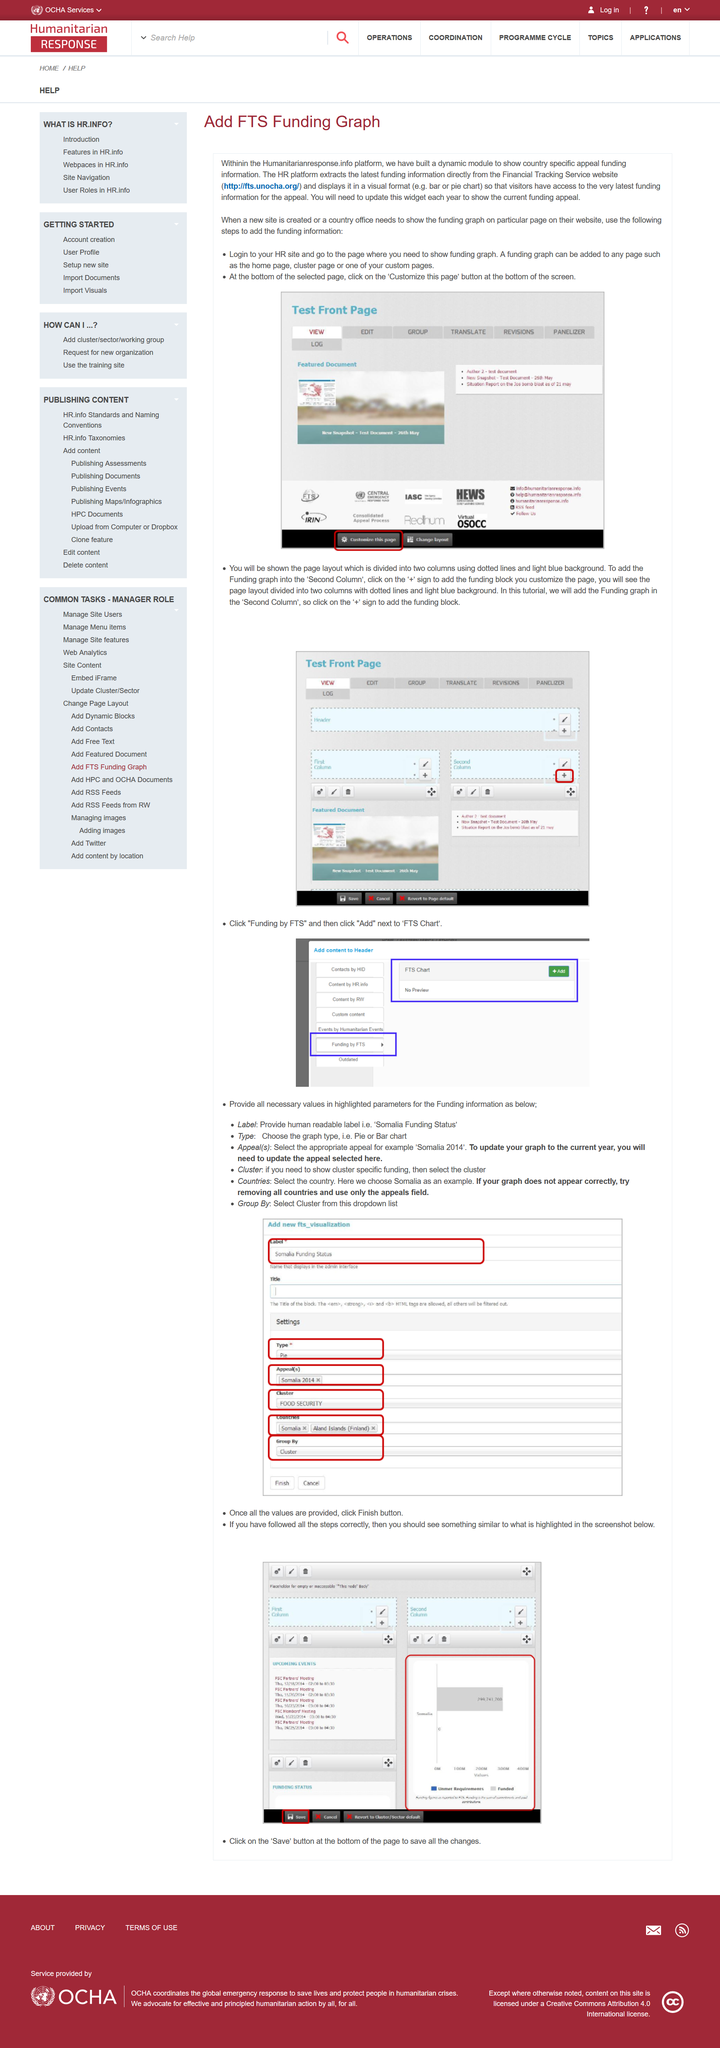Point out several critical features in this image. It is recommended to provide all necessary values in the highlighted parameters. The HR platform obtains information directly from the Financial Tracking Service website. To access the funding graph on the HR website, you must click the 'Customize this page' button located at the bottom of the page. You can add the funding graph to the second column by clicking on the "+" sign and selecting the funding block. To save changes, you must click on the save button located at the bottom of the page. 